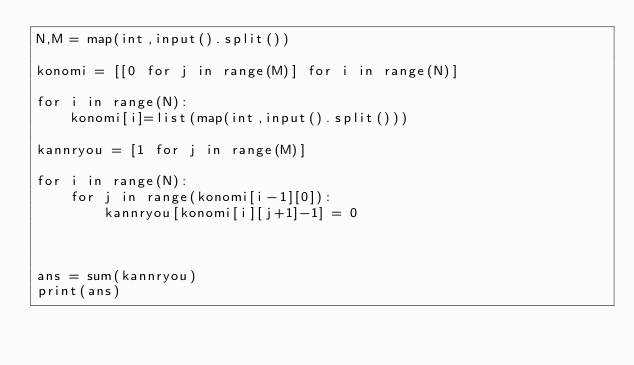Convert code to text. <code><loc_0><loc_0><loc_500><loc_500><_Python_>N,M = map(int,input().split())

konomi = [[0 for j in range(M)] for i in range(N)]

for i in range(N):
    konomi[i]=list(map(int,input().split()))

kannryou = [1 for j in range(M)]

for i in range(N):
    for j in range(konomi[i-1][0]):
        kannryou[konomi[i][j+1]-1] = 0


        
ans = sum(kannryou)
print(ans)</code> 